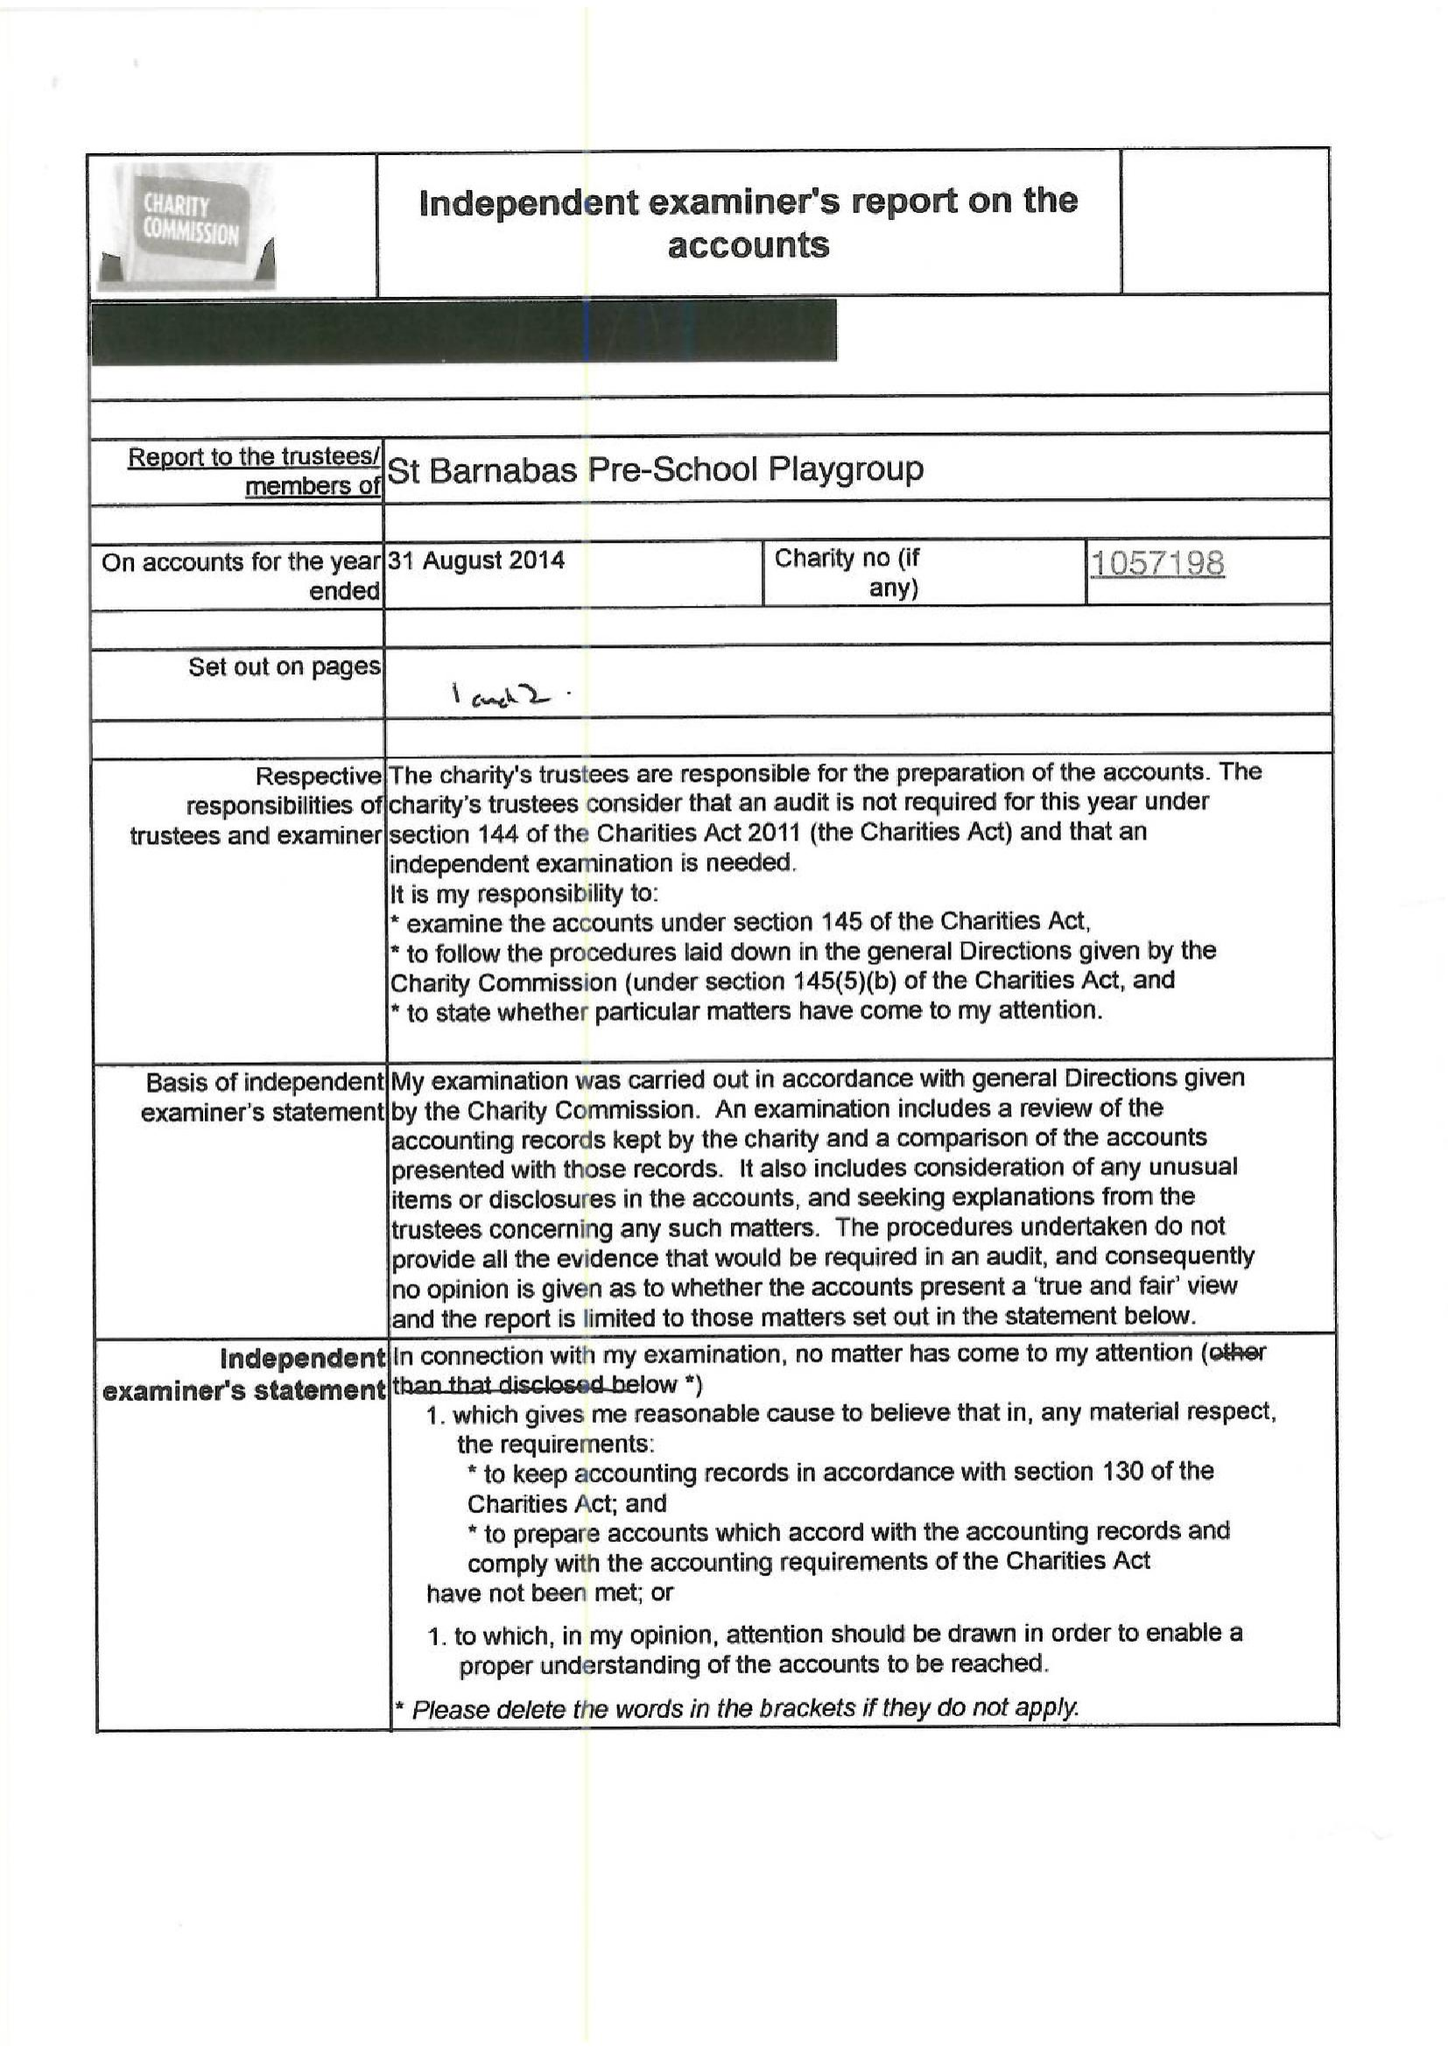What is the value for the report_date?
Answer the question using a single word or phrase. 2014-08-31 